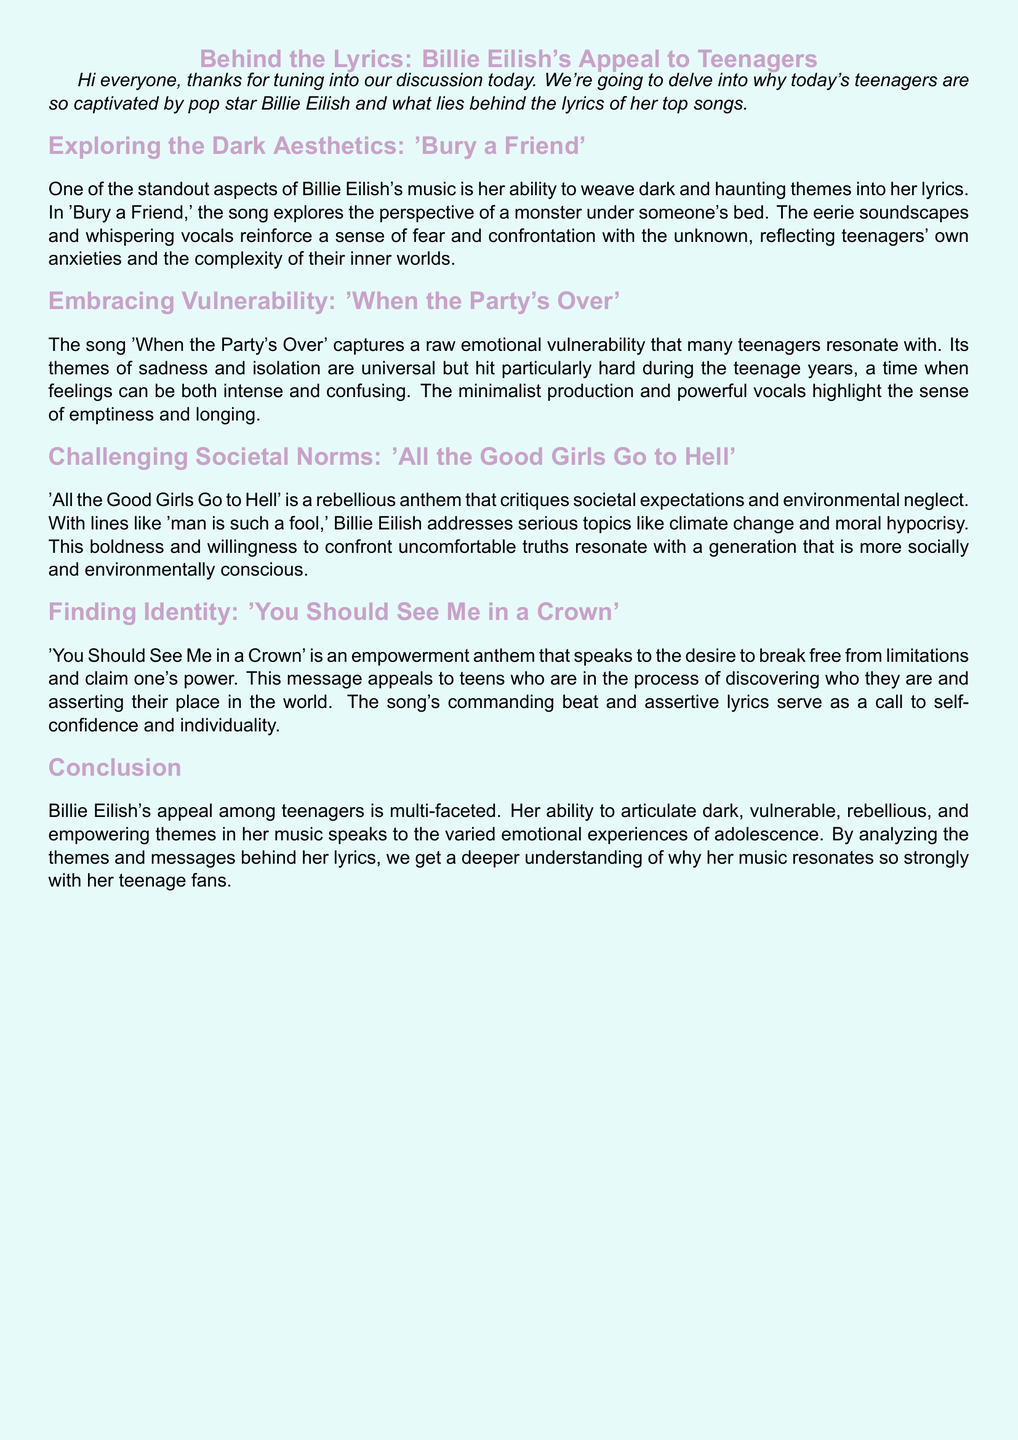what is the title of the discussion? The title of the discussion is presented at the beginning of the document.
Answer: Behind the Lyrics: Billie Eilish's Appeal to Teenagers which song explores the perspective of a monster under someone's bed? The document mentions this song in the section discussing dark aesthetics.
Answer: Bury a Friend what emotion is particularly highlighted in 'When the Party's Over'? The song is noted for capturing a specific emotional experience.
Answer: Vulnerability which societal issue does 'All the Good Girls Go to Hell' critique? The song is associated with a specific theme mentioned in the document.
Answer: Climate change what does 'You Should See Me in a Crown' represent? This is identified in the document as what the song speaks to in terms of personal experience.
Answer: Empowerment what production style is used in 'When the Party's Over'? The document describes a specific characteristic of the song's production.
Answer: Minimalist production how does Billie Eilish's music resonate with teenagers? The conclusion describes a multi-faceted aspect of her appeal.
Answer: Emotional experiences what type of themes does Billie Eilish incorporate into her music? The document specifies the range of themes she explores.
Answer: Dark, vulnerable, rebellious, and empowering themes 